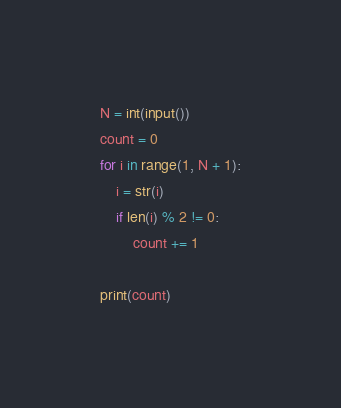Convert code to text. <code><loc_0><loc_0><loc_500><loc_500><_Python_>N = int(input())
count = 0
for i in range(1, N + 1):
    i = str(i)
    if len(i) % 2 != 0:
        count += 1

print(count)</code> 